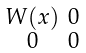<formula> <loc_0><loc_0><loc_500><loc_500>\begin{smallmatrix} W ( x ) & 0 \\ 0 & 0 \end{smallmatrix}</formula> 